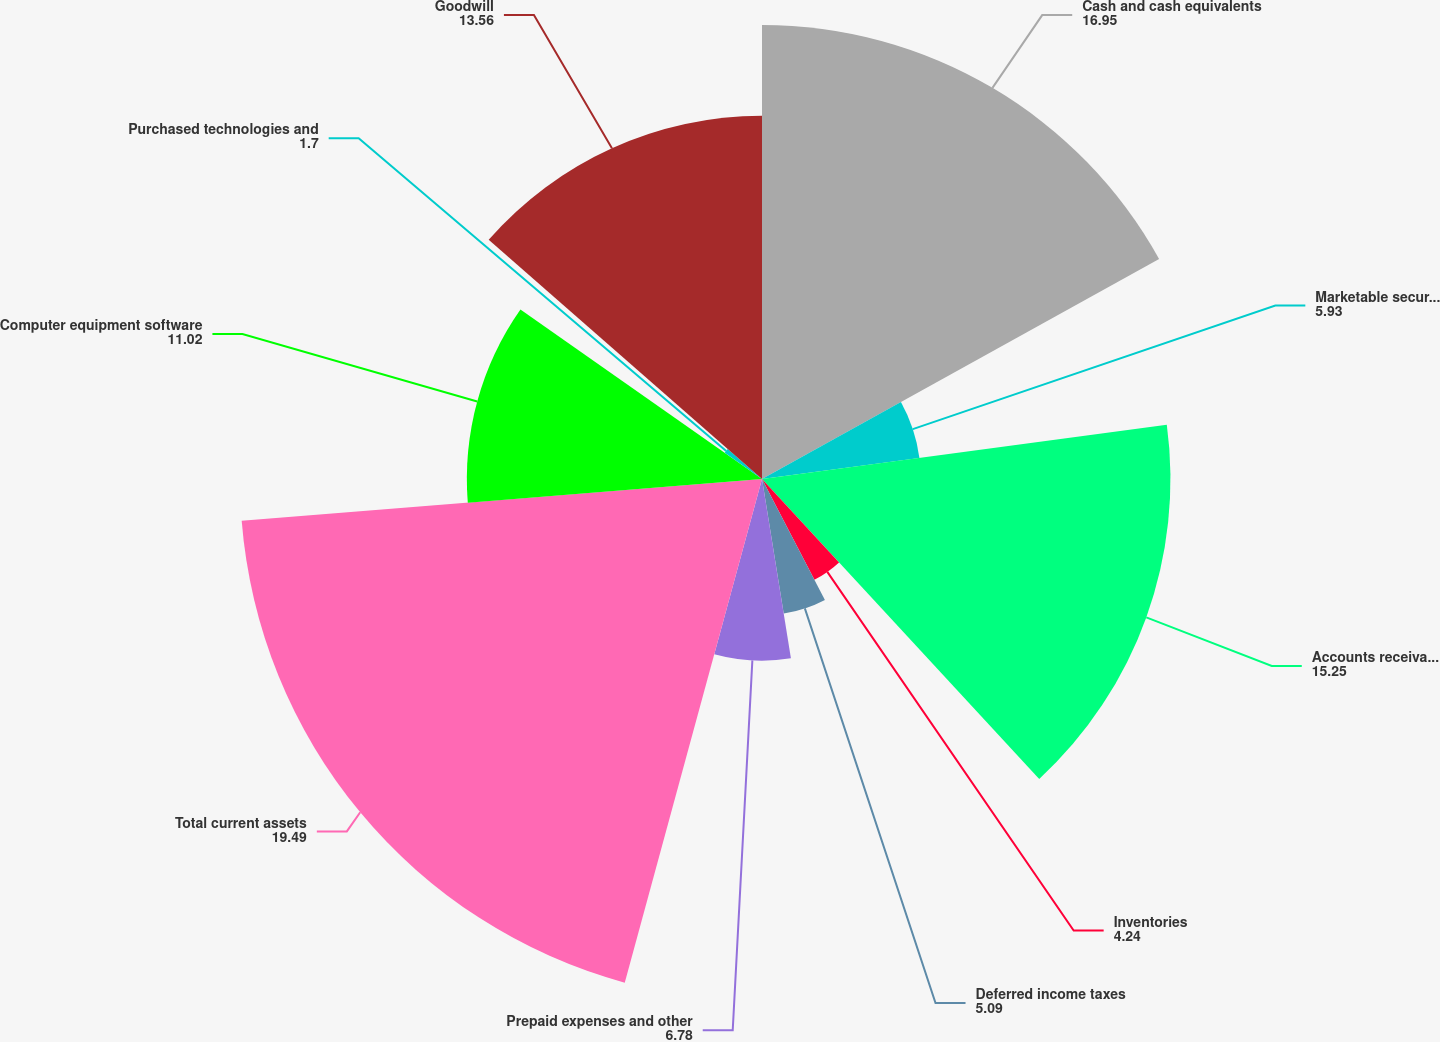<chart> <loc_0><loc_0><loc_500><loc_500><pie_chart><fcel>Cash and cash equivalents<fcel>Marketable securities<fcel>Accounts receivable net<fcel>Inventories<fcel>Deferred income taxes<fcel>Prepaid expenses and other<fcel>Total current assets<fcel>Computer equipment software<fcel>Purchased technologies and<fcel>Goodwill<nl><fcel>16.95%<fcel>5.93%<fcel>15.25%<fcel>4.24%<fcel>5.09%<fcel>6.78%<fcel>19.49%<fcel>11.02%<fcel>1.7%<fcel>13.56%<nl></chart> 